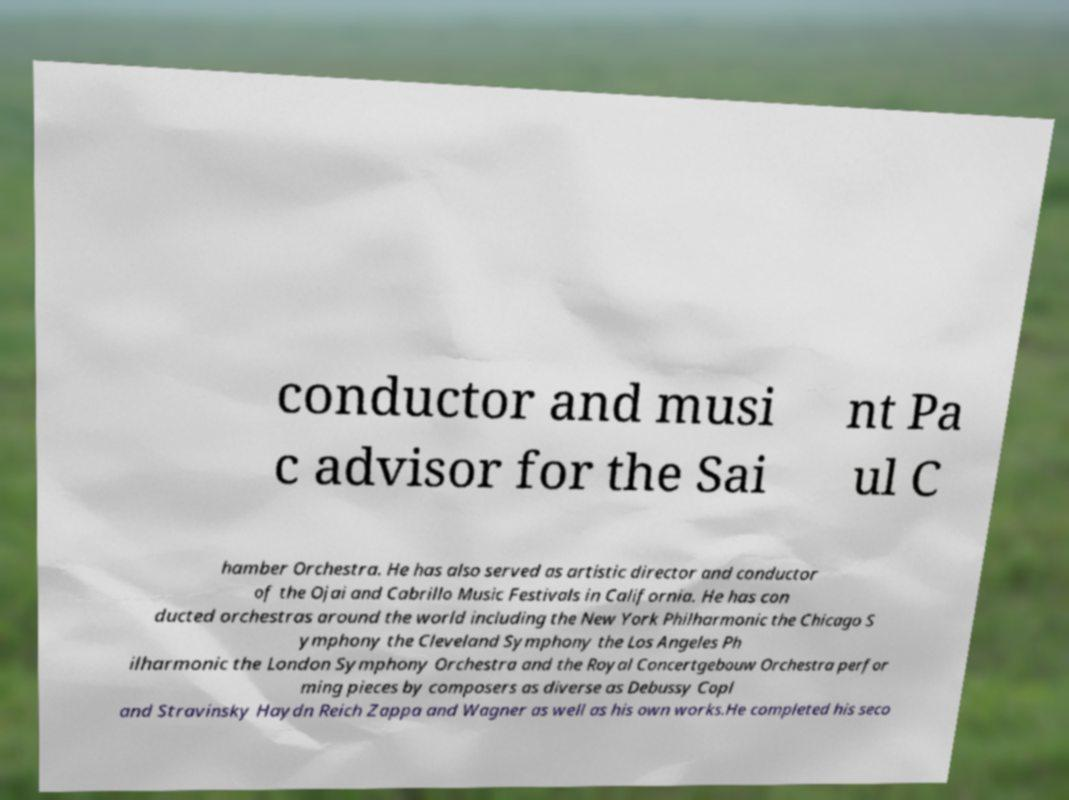Could you assist in decoding the text presented in this image and type it out clearly? conductor and musi c advisor for the Sai nt Pa ul C hamber Orchestra. He has also served as artistic director and conductor of the Ojai and Cabrillo Music Festivals in California. He has con ducted orchestras around the world including the New York Philharmonic the Chicago S ymphony the Cleveland Symphony the Los Angeles Ph ilharmonic the London Symphony Orchestra and the Royal Concertgebouw Orchestra perfor ming pieces by composers as diverse as Debussy Copl and Stravinsky Haydn Reich Zappa and Wagner as well as his own works.He completed his seco 